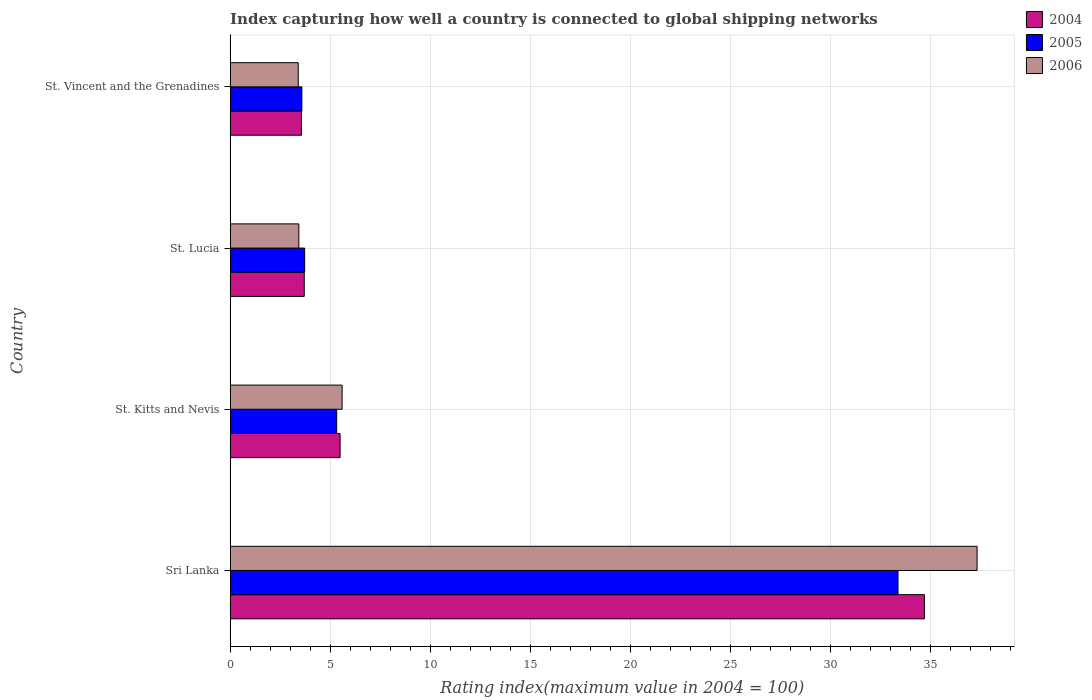How many groups of bars are there?
Offer a very short reply. 4. What is the label of the 1st group of bars from the top?
Your answer should be compact. St. Vincent and the Grenadines. In how many cases, is the number of bars for a given country not equal to the number of legend labels?
Keep it short and to the point. 0. What is the rating index in 2005 in St. Lucia?
Provide a succinct answer. 3.72. Across all countries, what is the maximum rating index in 2005?
Keep it short and to the point. 33.36. In which country was the rating index in 2006 maximum?
Make the answer very short. Sri Lanka. In which country was the rating index in 2004 minimum?
Offer a terse response. St. Vincent and the Grenadines. What is the total rating index in 2004 in the graph?
Your answer should be very brief. 47.43. What is the difference between the rating index in 2006 in St. Kitts and Nevis and that in St. Vincent and the Grenadines?
Ensure brevity in your answer.  2.19. What is the difference between the rating index in 2005 in St. Vincent and the Grenadines and the rating index in 2004 in St. Kitts and Nevis?
Provide a succinct answer. -1.91. What is the average rating index in 2006 per country?
Offer a terse response. 12.43. What is the difference between the rating index in 2005 and rating index in 2006 in St. Kitts and Nevis?
Provide a succinct answer. -0.27. In how many countries, is the rating index in 2006 greater than 9 ?
Make the answer very short. 1. What is the ratio of the rating index in 2004 in St. Lucia to that in St. Vincent and the Grenadines?
Ensure brevity in your answer.  1.04. What is the difference between the highest and the second highest rating index in 2006?
Your response must be concise. 31.72. What is the difference between the highest and the lowest rating index in 2006?
Your answer should be compact. 33.91. In how many countries, is the rating index in 2005 greater than the average rating index in 2005 taken over all countries?
Offer a terse response. 1. Is the sum of the rating index in 2004 in St. Lucia and St. Vincent and the Grenadines greater than the maximum rating index in 2005 across all countries?
Provide a succinct answer. No. How many bars are there?
Ensure brevity in your answer.  12. Are all the bars in the graph horizontal?
Give a very brief answer. Yes. How many countries are there in the graph?
Your response must be concise. 4. Does the graph contain any zero values?
Keep it short and to the point. No. Where does the legend appear in the graph?
Offer a very short reply. Top right. What is the title of the graph?
Make the answer very short. Index capturing how well a country is connected to global shipping networks. What is the label or title of the X-axis?
Make the answer very short. Rating index(maximum value in 2004 = 100). What is the label or title of the Y-axis?
Provide a succinct answer. Country. What is the Rating index(maximum value in 2004 = 100) in 2004 in Sri Lanka?
Your answer should be compact. 34.68. What is the Rating index(maximum value in 2004 = 100) of 2005 in Sri Lanka?
Your answer should be very brief. 33.36. What is the Rating index(maximum value in 2004 = 100) of 2006 in Sri Lanka?
Your answer should be very brief. 37.31. What is the Rating index(maximum value in 2004 = 100) of 2004 in St. Kitts and Nevis?
Offer a terse response. 5.49. What is the Rating index(maximum value in 2004 = 100) in 2005 in St. Kitts and Nevis?
Give a very brief answer. 5.32. What is the Rating index(maximum value in 2004 = 100) in 2006 in St. Kitts and Nevis?
Your response must be concise. 5.59. What is the Rating index(maximum value in 2004 = 100) of 2005 in St. Lucia?
Give a very brief answer. 3.72. What is the Rating index(maximum value in 2004 = 100) of 2006 in St. Lucia?
Provide a succinct answer. 3.43. What is the Rating index(maximum value in 2004 = 100) in 2004 in St. Vincent and the Grenadines?
Give a very brief answer. 3.56. What is the Rating index(maximum value in 2004 = 100) of 2005 in St. Vincent and the Grenadines?
Offer a terse response. 3.58. What is the Rating index(maximum value in 2004 = 100) in 2006 in St. Vincent and the Grenadines?
Make the answer very short. 3.4. Across all countries, what is the maximum Rating index(maximum value in 2004 = 100) in 2004?
Give a very brief answer. 34.68. Across all countries, what is the maximum Rating index(maximum value in 2004 = 100) in 2005?
Give a very brief answer. 33.36. Across all countries, what is the maximum Rating index(maximum value in 2004 = 100) in 2006?
Provide a short and direct response. 37.31. Across all countries, what is the minimum Rating index(maximum value in 2004 = 100) of 2004?
Your answer should be very brief. 3.56. Across all countries, what is the minimum Rating index(maximum value in 2004 = 100) of 2005?
Offer a terse response. 3.58. Across all countries, what is the minimum Rating index(maximum value in 2004 = 100) of 2006?
Provide a succinct answer. 3.4. What is the total Rating index(maximum value in 2004 = 100) in 2004 in the graph?
Offer a terse response. 47.43. What is the total Rating index(maximum value in 2004 = 100) in 2005 in the graph?
Offer a terse response. 45.98. What is the total Rating index(maximum value in 2004 = 100) in 2006 in the graph?
Your answer should be compact. 49.73. What is the difference between the Rating index(maximum value in 2004 = 100) in 2004 in Sri Lanka and that in St. Kitts and Nevis?
Give a very brief answer. 29.19. What is the difference between the Rating index(maximum value in 2004 = 100) in 2005 in Sri Lanka and that in St. Kitts and Nevis?
Provide a short and direct response. 28.04. What is the difference between the Rating index(maximum value in 2004 = 100) of 2006 in Sri Lanka and that in St. Kitts and Nevis?
Your answer should be compact. 31.72. What is the difference between the Rating index(maximum value in 2004 = 100) in 2004 in Sri Lanka and that in St. Lucia?
Give a very brief answer. 30.98. What is the difference between the Rating index(maximum value in 2004 = 100) of 2005 in Sri Lanka and that in St. Lucia?
Provide a succinct answer. 29.64. What is the difference between the Rating index(maximum value in 2004 = 100) of 2006 in Sri Lanka and that in St. Lucia?
Give a very brief answer. 33.88. What is the difference between the Rating index(maximum value in 2004 = 100) in 2004 in Sri Lanka and that in St. Vincent and the Grenadines?
Keep it short and to the point. 31.12. What is the difference between the Rating index(maximum value in 2004 = 100) of 2005 in Sri Lanka and that in St. Vincent and the Grenadines?
Make the answer very short. 29.78. What is the difference between the Rating index(maximum value in 2004 = 100) in 2006 in Sri Lanka and that in St. Vincent and the Grenadines?
Make the answer very short. 33.91. What is the difference between the Rating index(maximum value in 2004 = 100) in 2004 in St. Kitts and Nevis and that in St. Lucia?
Give a very brief answer. 1.79. What is the difference between the Rating index(maximum value in 2004 = 100) of 2005 in St. Kitts and Nevis and that in St. Lucia?
Provide a short and direct response. 1.6. What is the difference between the Rating index(maximum value in 2004 = 100) in 2006 in St. Kitts and Nevis and that in St. Lucia?
Make the answer very short. 2.16. What is the difference between the Rating index(maximum value in 2004 = 100) of 2004 in St. Kitts and Nevis and that in St. Vincent and the Grenadines?
Offer a very short reply. 1.93. What is the difference between the Rating index(maximum value in 2004 = 100) of 2005 in St. Kitts and Nevis and that in St. Vincent and the Grenadines?
Keep it short and to the point. 1.74. What is the difference between the Rating index(maximum value in 2004 = 100) in 2006 in St. Kitts and Nevis and that in St. Vincent and the Grenadines?
Your answer should be very brief. 2.19. What is the difference between the Rating index(maximum value in 2004 = 100) in 2004 in St. Lucia and that in St. Vincent and the Grenadines?
Ensure brevity in your answer.  0.14. What is the difference between the Rating index(maximum value in 2004 = 100) of 2005 in St. Lucia and that in St. Vincent and the Grenadines?
Your answer should be very brief. 0.14. What is the difference between the Rating index(maximum value in 2004 = 100) in 2006 in St. Lucia and that in St. Vincent and the Grenadines?
Offer a very short reply. 0.03. What is the difference between the Rating index(maximum value in 2004 = 100) in 2004 in Sri Lanka and the Rating index(maximum value in 2004 = 100) in 2005 in St. Kitts and Nevis?
Keep it short and to the point. 29.36. What is the difference between the Rating index(maximum value in 2004 = 100) in 2004 in Sri Lanka and the Rating index(maximum value in 2004 = 100) in 2006 in St. Kitts and Nevis?
Ensure brevity in your answer.  29.09. What is the difference between the Rating index(maximum value in 2004 = 100) in 2005 in Sri Lanka and the Rating index(maximum value in 2004 = 100) in 2006 in St. Kitts and Nevis?
Ensure brevity in your answer.  27.77. What is the difference between the Rating index(maximum value in 2004 = 100) of 2004 in Sri Lanka and the Rating index(maximum value in 2004 = 100) of 2005 in St. Lucia?
Give a very brief answer. 30.96. What is the difference between the Rating index(maximum value in 2004 = 100) in 2004 in Sri Lanka and the Rating index(maximum value in 2004 = 100) in 2006 in St. Lucia?
Make the answer very short. 31.25. What is the difference between the Rating index(maximum value in 2004 = 100) in 2005 in Sri Lanka and the Rating index(maximum value in 2004 = 100) in 2006 in St. Lucia?
Your response must be concise. 29.93. What is the difference between the Rating index(maximum value in 2004 = 100) in 2004 in Sri Lanka and the Rating index(maximum value in 2004 = 100) in 2005 in St. Vincent and the Grenadines?
Keep it short and to the point. 31.1. What is the difference between the Rating index(maximum value in 2004 = 100) in 2004 in Sri Lanka and the Rating index(maximum value in 2004 = 100) in 2006 in St. Vincent and the Grenadines?
Offer a very short reply. 31.28. What is the difference between the Rating index(maximum value in 2004 = 100) of 2005 in Sri Lanka and the Rating index(maximum value in 2004 = 100) of 2006 in St. Vincent and the Grenadines?
Ensure brevity in your answer.  29.96. What is the difference between the Rating index(maximum value in 2004 = 100) in 2004 in St. Kitts and Nevis and the Rating index(maximum value in 2004 = 100) in 2005 in St. Lucia?
Offer a very short reply. 1.77. What is the difference between the Rating index(maximum value in 2004 = 100) in 2004 in St. Kitts and Nevis and the Rating index(maximum value in 2004 = 100) in 2006 in St. Lucia?
Your answer should be compact. 2.06. What is the difference between the Rating index(maximum value in 2004 = 100) in 2005 in St. Kitts and Nevis and the Rating index(maximum value in 2004 = 100) in 2006 in St. Lucia?
Your response must be concise. 1.89. What is the difference between the Rating index(maximum value in 2004 = 100) of 2004 in St. Kitts and Nevis and the Rating index(maximum value in 2004 = 100) of 2005 in St. Vincent and the Grenadines?
Provide a short and direct response. 1.91. What is the difference between the Rating index(maximum value in 2004 = 100) of 2004 in St. Kitts and Nevis and the Rating index(maximum value in 2004 = 100) of 2006 in St. Vincent and the Grenadines?
Offer a very short reply. 2.09. What is the difference between the Rating index(maximum value in 2004 = 100) in 2005 in St. Kitts and Nevis and the Rating index(maximum value in 2004 = 100) in 2006 in St. Vincent and the Grenadines?
Offer a very short reply. 1.92. What is the difference between the Rating index(maximum value in 2004 = 100) of 2004 in St. Lucia and the Rating index(maximum value in 2004 = 100) of 2005 in St. Vincent and the Grenadines?
Your answer should be compact. 0.12. What is the difference between the Rating index(maximum value in 2004 = 100) in 2005 in St. Lucia and the Rating index(maximum value in 2004 = 100) in 2006 in St. Vincent and the Grenadines?
Provide a succinct answer. 0.32. What is the average Rating index(maximum value in 2004 = 100) in 2004 per country?
Your response must be concise. 11.86. What is the average Rating index(maximum value in 2004 = 100) of 2005 per country?
Ensure brevity in your answer.  11.49. What is the average Rating index(maximum value in 2004 = 100) in 2006 per country?
Ensure brevity in your answer.  12.43. What is the difference between the Rating index(maximum value in 2004 = 100) of 2004 and Rating index(maximum value in 2004 = 100) of 2005 in Sri Lanka?
Your response must be concise. 1.32. What is the difference between the Rating index(maximum value in 2004 = 100) in 2004 and Rating index(maximum value in 2004 = 100) in 2006 in Sri Lanka?
Offer a very short reply. -2.63. What is the difference between the Rating index(maximum value in 2004 = 100) in 2005 and Rating index(maximum value in 2004 = 100) in 2006 in Sri Lanka?
Make the answer very short. -3.95. What is the difference between the Rating index(maximum value in 2004 = 100) of 2004 and Rating index(maximum value in 2004 = 100) of 2005 in St. Kitts and Nevis?
Provide a short and direct response. 0.17. What is the difference between the Rating index(maximum value in 2004 = 100) in 2004 and Rating index(maximum value in 2004 = 100) in 2006 in St. Kitts and Nevis?
Your response must be concise. -0.1. What is the difference between the Rating index(maximum value in 2004 = 100) in 2005 and Rating index(maximum value in 2004 = 100) in 2006 in St. Kitts and Nevis?
Your answer should be compact. -0.27. What is the difference between the Rating index(maximum value in 2004 = 100) of 2004 and Rating index(maximum value in 2004 = 100) of 2005 in St. Lucia?
Provide a succinct answer. -0.02. What is the difference between the Rating index(maximum value in 2004 = 100) of 2004 and Rating index(maximum value in 2004 = 100) of 2006 in St. Lucia?
Your answer should be very brief. 0.27. What is the difference between the Rating index(maximum value in 2004 = 100) of 2005 and Rating index(maximum value in 2004 = 100) of 2006 in St. Lucia?
Offer a very short reply. 0.29. What is the difference between the Rating index(maximum value in 2004 = 100) of 2004 and Rating index(maximum value in 2004 = 100) of 2005 in St. Vincent and the Grenadines?
Your answer should be very brief. -0.02. What is the difference between the Rating index(maximum value in 2004 = 100) in 2004 and Rating index(maximum value in 2004 = 100) in 2006 in St. Vincent and the Grenadines?
Your response must be concise. 0.16. What is the difference between the Rating index(maximum value in 2004 = 100) in 2005 and Rating index(maximum value in 2004 = 100) in 2006 in St. Vincent and the Grenadines?
Your response must be concise. 0.18. What is the ratio of the Rating index(maximum value in 2004 = 100) of 2004 in Sri Lanka to that in St. Kitts and Nevis?
Your answer should be compact. 6.32. What is the ratio of the Rating index(maximum value in 2004 = 100) in 2005 in Sri Lanka to that in St. Kitts and Nevis?
Your response must be concise. 6.27. What is the ratio of the Rating index(maximum value in 2004 = 100) of 2006 in Sri Lanka to that in St. Kitts and Nevis?
Your response must be concise. 6.67. What is the ratio of the Rating index(maximum value in 2004 = 100) in 2004 in Sri Lanka to that in St. Lucia?
Provide a succinct answer. 9.37. What is the ratio of the Rating index(maximum value in 2004 = 100) in 2005 in Sri Lanka to that in St. Lucia?
Make the answer very short. 8.97. What is the ratio of the Rating index(maximum value in 2004 = 100) of 2006 in Sri Lanka to that in St. Lucia?
Provide a short and direct response. 10.88. What is the ratio of the Rating index(maximum value in 2004 = 100) in 2004 in Sri Lanka to that in St. Vincent and the Grenadines?
Provide a succinct answer. 9.74. What is the ratio of the Rating index(maximum value in 2004 = 100) in 2005 in Sri Lanka to that in St. Vincent and the Grenadines?
Your response must be concise. 9.32. What is the ratio of the Rating index(maximum value in 2004 = 100) in 2006 in Sri Lanka to that in St. Vincent and the Grenadines?
Offer a terse response. 10.97. What is the ratio of the Rating index(maximum value in 2004 = 100) in 2004 in St. Kitts and Nevis to that in St. Lucia?
Make the answer very short. 1.48. What is the ratio of the Rating index(maximum value in 2004 = 100) of 2005 in St. Kitts and Nevis to that in St. Lucia?
Your answer should be compact. 1.43. What is the ratio of the Rating index(maximum value in 2004 = 100) of 2006 in St. Kitts and Nevis to that in St. Lucia?
Your response must be concise. 1.63. What is the ratio of the Rating index(maximum value in 2004 = 100) of 2004 in St. Kitts and Nevis to that in St. Vincent and the Grenadines?
Your response must be concise. 1.54. What is the ratio of the Rating index(maximum value in 2004 = 100) of 2005 in St. Kitts and Nevis to that in St. Vincent and the Grenadines?
Ensure brevity in your answer.  1.49. What is the ratio of the Rating index(maximum value in 2004 = 100) in 2006 in St. Kitts and Nevis to that in St. Vincent and the Grenadines?
Provide a short and direct response. 1.64. What is the ratio of the Rating index(maximum value in 2004 = 100) of 2004 in St. Lucia to that in St. Vincent and the Grenadines?
Offer a terse response. 1.04. What is the ratio of the Rating index(maximum value in 2004 = 100) of 2005 in St. Lucia to that in St. Vincent and the Grenadines?
Provide a succinct answer. 1.04. What is the ratio of the Rating index(maximum value in 2004 = 100) of 2006 in St. Lucia to that in St. Vincent and the Grenadines?
Offer a terse response. 1.01. What is the difference between the highest and the second highest Rating index(maximum value in 2004 = 100) in 2004?
Your answer should be compact. 29.19. What is the difference between the highest and the second highest Rating index(maximum value in 2004 = 100) in 2005?
Your response must be concise. 28.04. What is the difference between the highest and the second highest Rating index(maximum value in 2004 = 100) of 2006?
Offer a terse response. 31.72. What is the difference between the highest and the lowest Rating index(maximum value in 2004 = 100) in 2004?
Your answer should be very brief. 31.12. What is the difference between the highest and the lowest Rating index(maximum value in 2004 = 100) of 2005?
Your answer should be very brief. 29.78. What is the difference between the highest and the lowest Rating index(maximum value in 2004 = 100) of 2006?
Give a very brief answer. 33.91. 